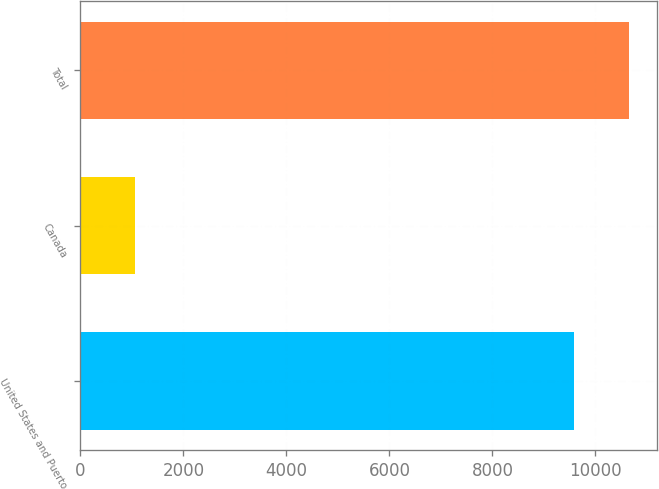Convert chart. <chart><loc_0><loc_0><loc_500><loc_500><bar_chart><fcel>United States and Puerto<fcel>Canada<fcel>Total<nl><fcel>9586<fcel>1071<fcel>10657<nl></chart> 